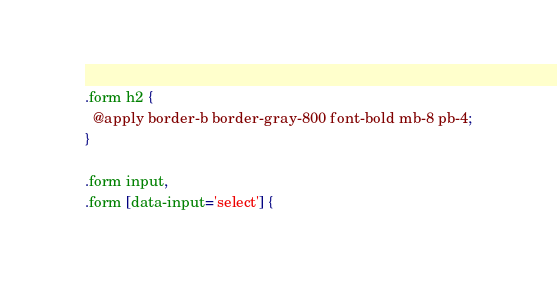Convert code to text. <code><loc_0><loc_0><loc_500><loc_500><_CSS_>.form h2 {
  @apply border-b border-gray-800 font-bold mb-8 pb-4;
}

.form input,
.form [data-input='select'] {</code> 